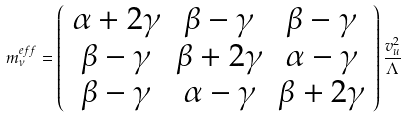Convert formula to latex. <formula><loc_0><loc_0><loc_500><loc_500>m ^ { e f f } _ { \nu } = \left ( \begin{array} { c c c } \alpha + 2 \gamma & \beta - \gamma & \beta - \gamma \\ \beta - \gamma & \beta + 2 \gamma & \alpha - \gamma \\ \beta - \gamma & \alpha - \gamma & \beta + 2 \gamma \end{array} \right ) \frac { v ^ { 2 } _ { u } } { \Lambda }</formula> 